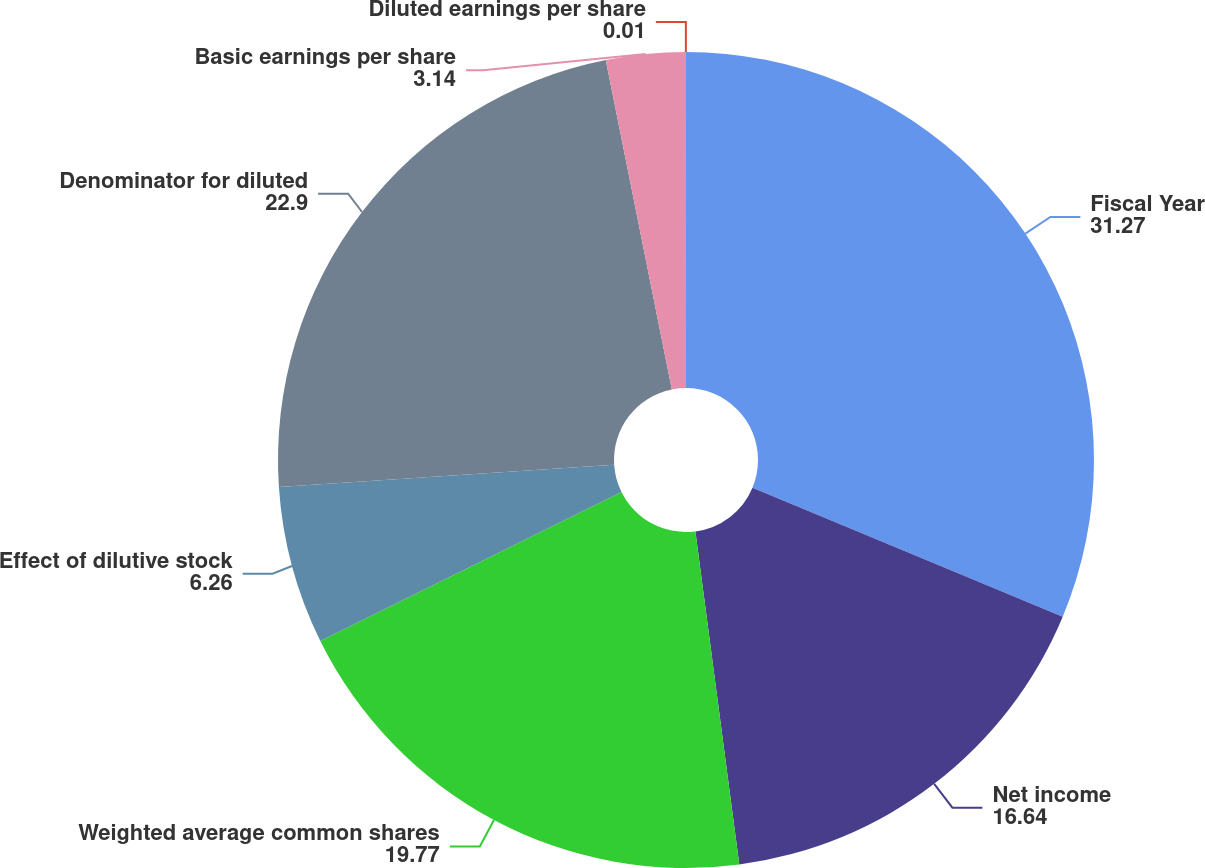Convert chart to OTSL. <chart><loc_0><loc_0><loc_500><loc_500><pie_chart><fcel>Fiscal Year<fcel>Net income<fcel>Weighted average common shares<fcel>Effect of dilutive stock<fcel>Denominator for diluted<fcel>Basic earnings per share<fcel>Diluted earnings per share<nl><fcel>31.27%<fcel>16.64%<fcel>19.77%<fcel>6.26%<fcel>22.9%<fcel>3.14%<fcel>0.01%<nl></chart> 